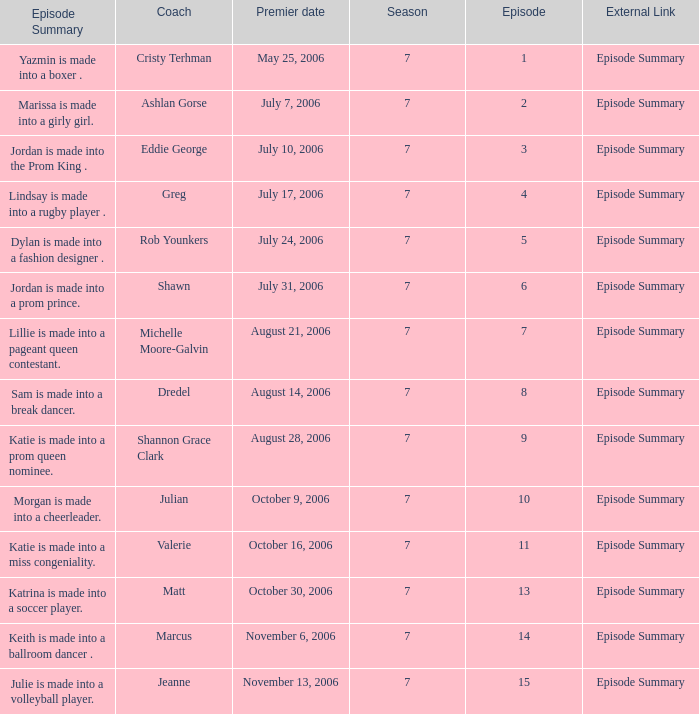How many episodes have Valerie? 1.0. Would you mind parsing the complete table? {'header': ['Episode Summary', 'Coach', 'Premier date', 'Season', 'Episode', 'External Link'], 'rows': [['Yazmin is made into a boxer .', 'Cristy Terhman', 'May 25, 2006', '7', '1', 'Episode Summary'], ['Marissa is made into a girly girl.', 'Ashlan Gorse', 'July 7, 2006', '7', '2', 'Episode Summary'], ['Jordan is made into the Prom King .', 'Eddie George', 'July 10, 2006', '7', '3', 'Episode Summary'], ['Lindsay is made into a rugby player .', 'Greg', 'July 17, 2006', '7', '4', 'Episode Summary'], ['Dylan is made into a fashion designer .', 'Rob Younkers', 'July 24, 2006', '7', '5', 'Episode Summary'], ['Jordan is made into a prom prince.', 'Shawn', 'July 31, 2006', '7', '6', 'Episode Summary'], ['Lillie is made into a pageant queen contestant.', 'Michelle Moore-Galvin', 'August 21, 2006', '7', '7', 'Episode Summary'], ['Sam is made into a break dancer.', 'Dredel', 'August 14, 2006', '7', '8', 'Episode Summary'], ['Katie is made into a prom queen nominee.', 'Shannon Grace Clark', 'August 28, 2006', '7', '9', 'Episode Summary'], ['Morgan is made into a cheerleader.', 'Julian', 'October 9, 2006', '7', '10', 'Episode Summary'], ['Katie is made into a miss congeniality.', 'Valerie', 'October 16, 2006', '7', '11', 'Episode Summary'], ['Katrina is made into a soccer player.', 'Matt', 'October 30, 2006', '7', '13', 'Episode Summary'], ['Keith is made into a ballroom dancer .', 'Marcus', 'November 6, 2006', '7', '14', 'Episode Summary'], ['Julie is made into a volleyball player.', 'Jeanne', 'November 13, 2006', '7', '15', 'Episode Summary']]} 